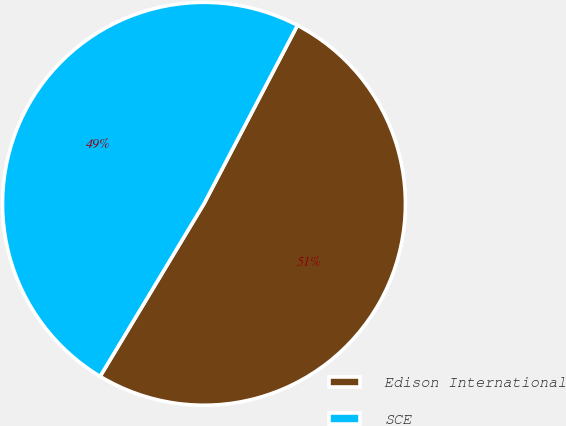<chart> <loc_0><loc_0><loc_500><loc_500><pie_chart><fcel>Edison International<fcel>SCE<nl><fcel>50.94%<fcel>49.06%<nl></chart> 